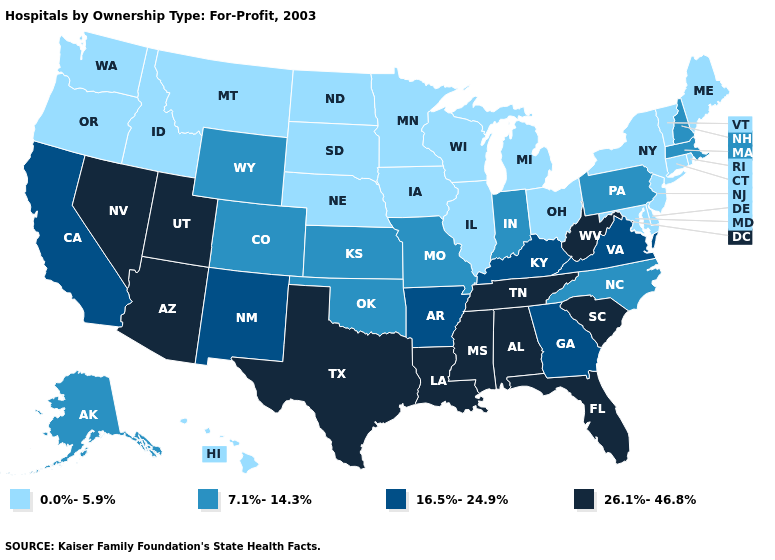Name the states that have a value in the range 7.1%-14.3%?
Answer briefly. Alaska, Colorado, Indiana, Kansas, Massachusetts, Missouri, New Hampshire, North Carolina, Oklahoma, Pennsylvania, Wyoming. What is the lowest value in the USA?
Quick response, please. 0.0%-5.9%. What is the lowest value in the USA?
Keep it brief. 0.0%-5.9%. What is the value of Nevada?
Short answer required. 26.1%-46.8%. What is the value of Washington?
Keep it brief. 0.0%-5.9%. Name the states that have a value in the range 7.1%-14.3%?
Short answer required. Alaska, Colorado, Indiana, Kansas, Massachusetts, Missouri, New Hampshire, North Carolina, Oklahoma, Pennsylvania, Wyoming. Among the states that border Ohio , which have the lowest value?
Keep it brief. Michigan. Is the legend a continuous bar?
Give a very brief answer. No. Among the states that border Florida , which have the lowest value?
Keep it brief. Georgia. Name the states that have a value in the range 7.1%-14.3%?
Be succinct. Alaska, Colorado, Indiana, Kansas, Massachusetts, Missouri, New Hampshire, North Carolina, Oklahoma, Pennsylvania, Wyoming. Does the map have missing data?
Concise answer only. No. Does Kentucky have the same value as Vermont?
Concise answer only. No. Which states have the lowest value in the South?
Be succinct. Delaware, Maryland. Name the states that have a value in the range 0.0%-5.9%?
Quick response, please. Connecticut, Delaware, Hawaii, Idaho, Illinois, Iowa, Maine, Maryland, Michigan, Minnesota, Montana, Nebraska, New Jersey, New York, North Dakota, Ohio, Oregon, Rhode Island, South Dakota, Vermont, Washington, Wisconsin. Among the states that border Kentucky , which have the highest value?
Short answer required. Tennessee, West Virginia. 